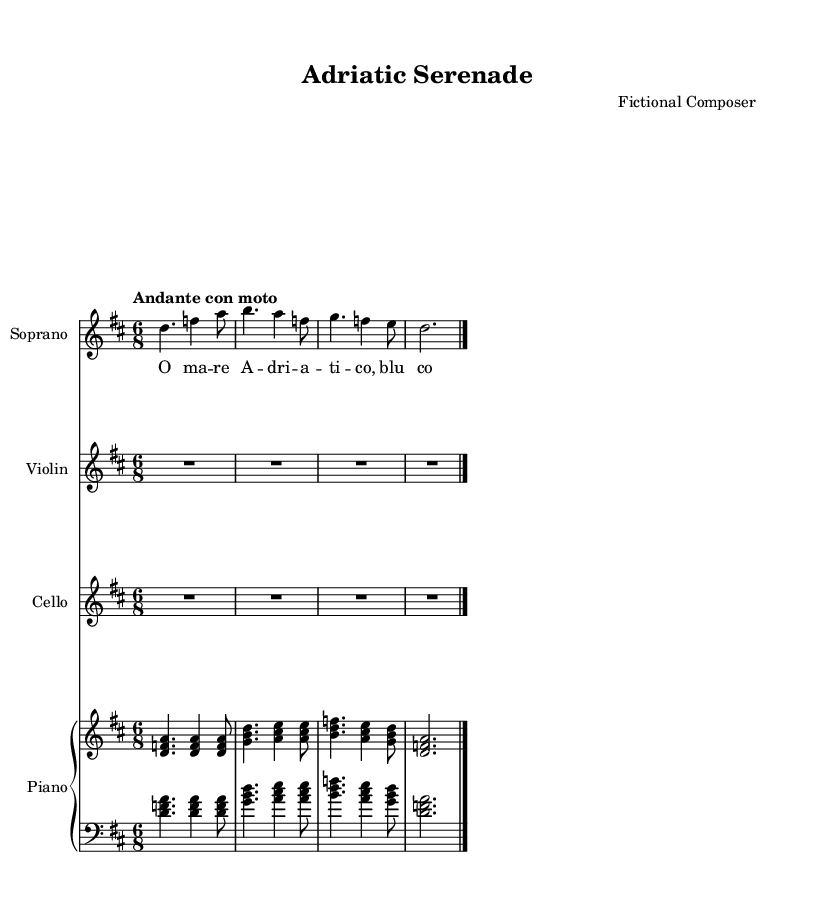What is the key signature of this music? The key signature is D major, which has two sharps (F# and C#). You can observe the key signature indicated at the beginning of the music.
Answer: D major What is the time signature of this music? The time signature is 6/8, which is indicated by the notation at the beginning of the score. This means there are 6 eighth notes per measure.
Answer: 6/8 What is the tempo marking of this piece? The tempo marking is "Andante con moto," which can be found in the tempo indication at the beginning of the score. This suggests a moderately slow pace with a bit of motion.
Answer: Andante con moto How many measures are in the soprano part before it ends? The soprano part consists of one complete measure followed by a final ending measure. Counting these, there are 4 measures total.
Answer: 4 What dynamic marking is indicated in the soprano part? The dynamic marking is "mf" (mezzo-forte) followed by "f" (forte) for a more forceful sound. The "mf" is found before the first note, and "f" appears before the final note.
Answer: mf, f What lyrical theme do the lyrics suggest? The lyrics refer to the Adriatic Sea by mentioning "Adriatico," and express a poetic image of beauty with the phrase "blu come il cielo," which translates to "blue like the sky," emphasizing the coastal life theme.
Answer: Adriatic Sea 